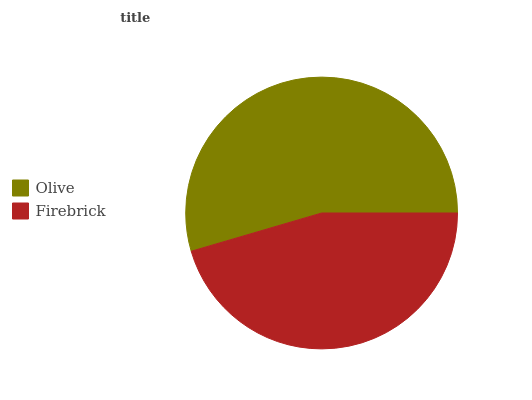Is Firebrick the minimum?
Answer yes or no. Yes. Is Olive the maximum?
Answer yes or no. Yes. Is Firebrick the maximum?
Answer yes or no. No. Is Olive greater than Firebrick?
Answer yes or no. Yes. Is Firebrick less than Olive?
Answer yes or no. Yes. Is Firebrick greater than Olive?
Answer yes or no. No. Is Olive less than Firebrick?
Answer yes or no. No. Is Olive the high median?
Answer yes or no. Yes. Is Firebrick the low median?
Answer yes or no. Yes. Is Firebrick the high median?
Answer yes or no. No. Is Olive the low median?
Answer yes or no. No. 